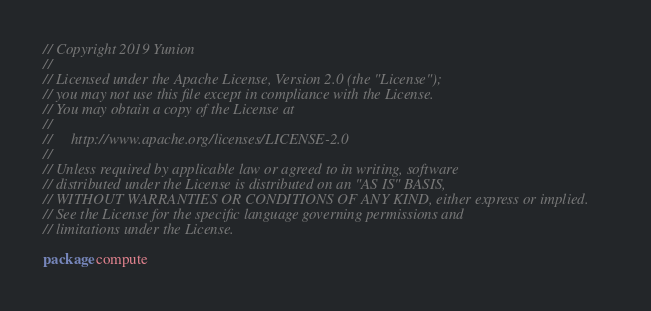Convert code to text. <code><loc_0><loc_0><loc_500><loc_500><_Go_>// Copyright 2019 Yunion
//
// Licensed under the Apache License, Version 2.0 (the "License");
// you may not use this file except in compliance with the License.
// You may obtain a copy of the License at
//
//     http://www.apache.org/licenses/LICENSE-2.0
//
// Unless required by applicable law or agreed to in writing, software
// distributed under the License is distributed on an "AS IS" BASIS,
// WITHOUT WARRANTIES OR CONDITIONS OF ANY KIND, either express or implied.
// See the License for the specific language governing permissions and
// limitations under the License.

package compute
</code> 